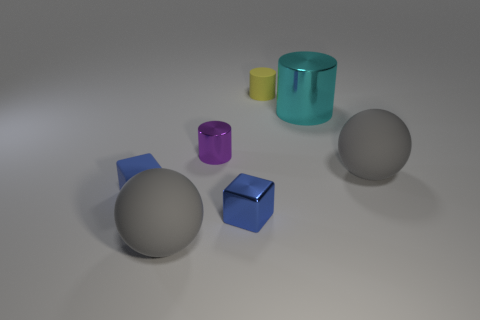What number of other things are there of the same material as the tiny purple cylinder
Your answer should be very brief. 2. What material is the blue object that is the same size as the shiny block?
Give a very brief answer. Rubber. Are there fewer cyan metallic objects behind the tiny yellow rubber object than big purple metallic cylinders?
Provide a succinct answer. No. The gray rubber object on the right side of the big matte object in front of the large gray rubber thing that is right of the purple thing is what shape?
Provide a succinct answer. Sphere. What is the size of the cube that is right of the small purple metallic thing?
Your answer should be very brief. Small. What is the shape of the other blue object that is the same size as the blue rubber object?
Your answer should be compact. Cube. What number of things are small cyan things or matte cylinders behind the purple metallic object?
Give a very brief answer. 1. There is a big rubber object that is in front of the gray object right of the big cyan thing; what number of big gray rubber balls are on the right side of it?
Provide a succinct answer. 1. There is a block that is made of the same material as the tiny purple cylinder; what color is it?
Offer a terse response. Blue. There is a rubber cylinder behind the metal block; does it have the same size as the purple metal cylinder?
Keep it short and to the point. Yes. 